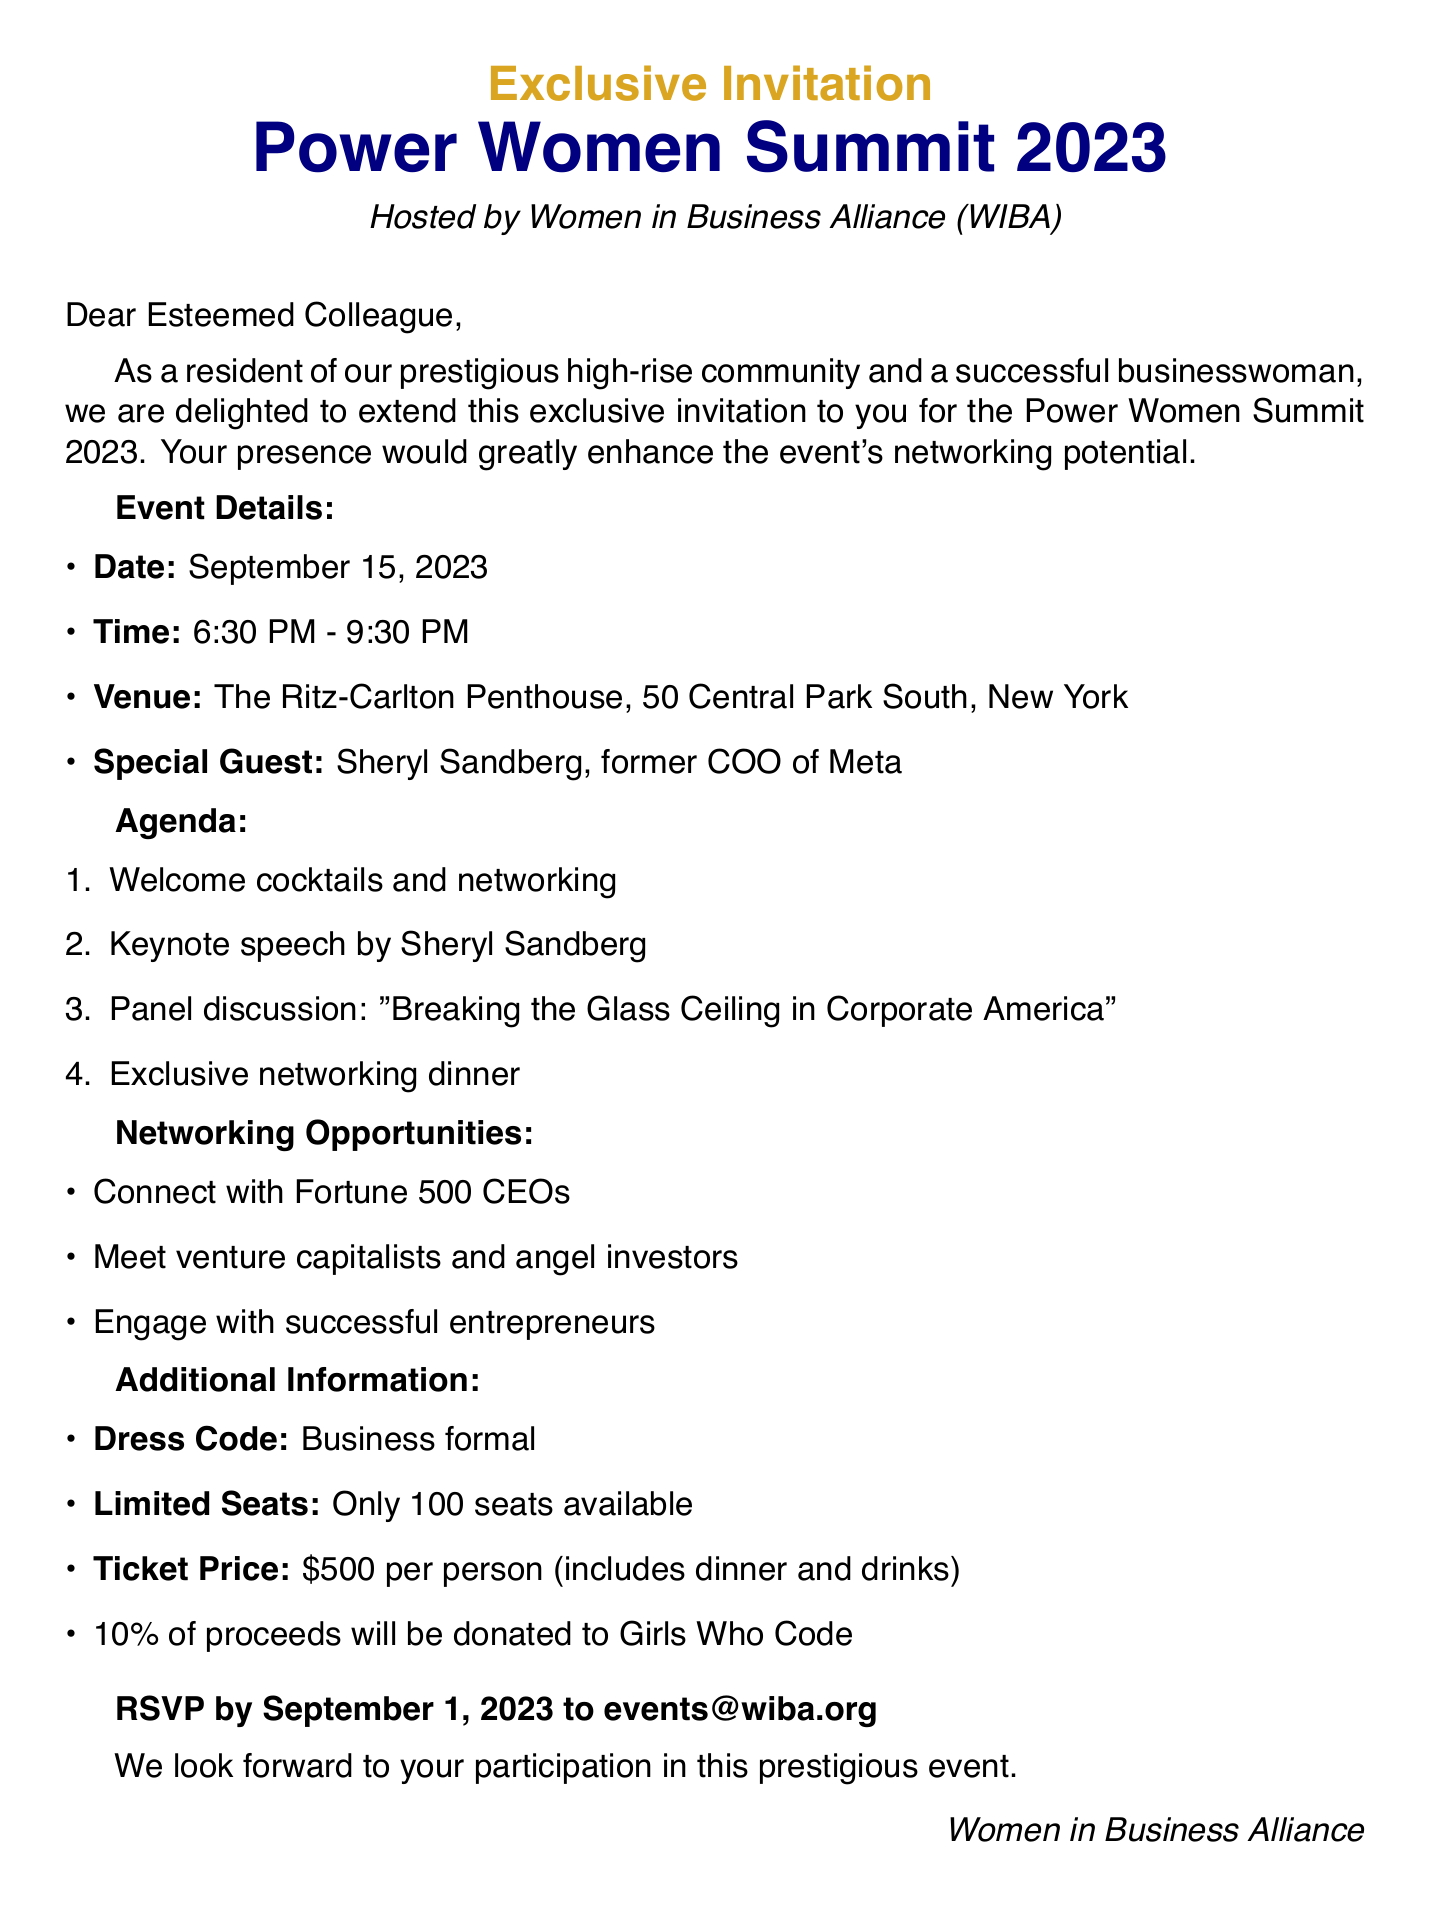what is the event name? The event name is clearly stated at the beginning of the document.
Answer: Power Women Summit 2023 who is the special guest? The document specifies Sheryl Sandberg as the special guest.
Answer: Sheryl Sandberg what is the ticket price? The ticket price is mentioned in the additional information section of the document.
Answer: $500 per person how many seats are available? The document indicates that there are a limited number of seats.
Answer: Only 100 seats available what is the date of the event? The date of the event is provided in the event details section.
Answer: September 15, 2023 what percentage of proceeds will be donated? The document includes a charitable component detailing the percentage donated.
Answer: 10% what type of networking opportunities are available? The document lists networking opportunities that can be connected with high-profile individuals.
Answer: Connect with Fortune 500 CEOs what is the RSVP deadline? The RSVP deadline is explicitly stated in the document.
Answer: September 1, 2023 what is the dress code? The dress code for the event is specified in the additional information section.
Answer: Business formal 